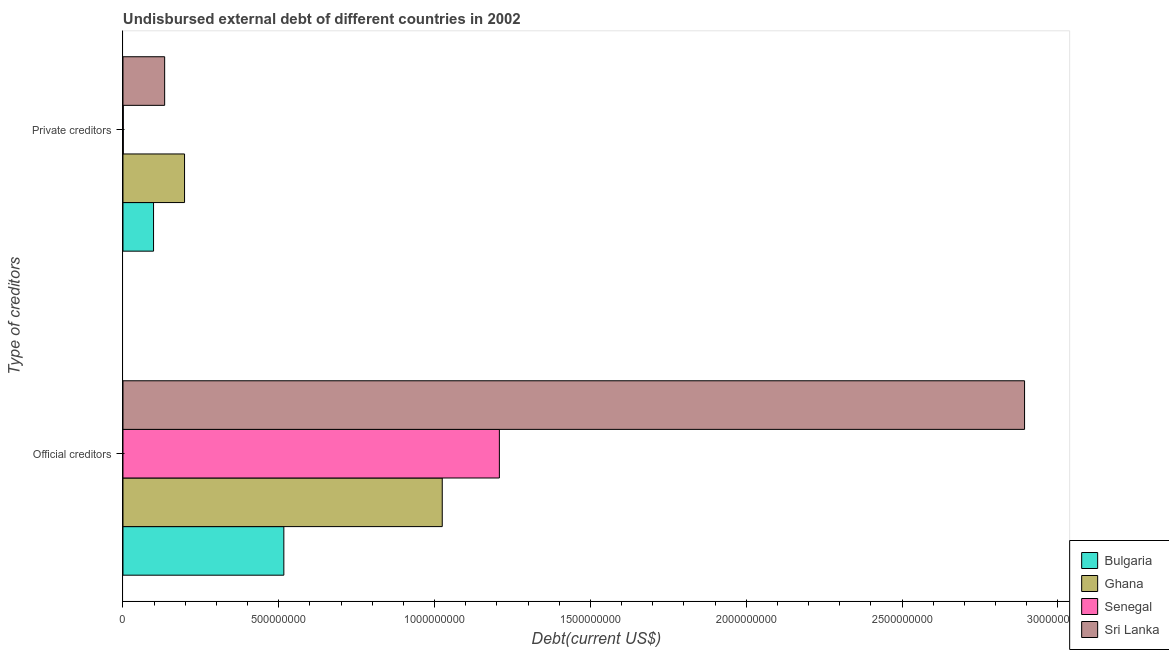How many different coloured bars are there?
Provide a short and direct response. 4. How many groups of bars are there?
Keep it short and to the point. 2. Are the number of bars per tick equal to the number of legend labels?
Your answer should be compact. Yes. Are the number of bars on each tick of the Y-axis equal?
Give a very brief answer. Yes. How many bars are there on the 2nd tick from the top?
Make the answer very short. 4. What is the label of the 1st group of bars from the top?
Ensure brevity in your answer.  Private creditors. What is the undisbursed external debt of private creditors in Ghana?
Offer a very short reply. 1.98e+08. Across all countries, what is the maximum undisbursed external debt of official creditors?
Offer a terse response. 2.89e+09. Across all countries, what is the minimum undisbursed external debt of private creditors?
Offer a very short reply. 9.55e+05. In which country was the undisbursed external debt of official creditors maximum?
Provide a succinct answer. Sri Lanka. In which country was the undisbursed external debt of private creditors minimum?
Your answer should be compact. Senegal. What is the total undisbursed external debt of official creditors in the graph?
Ensure brevity in your answer.  5.64e+09. What is the difference between the undisbursed external debt of private creditors in Sri Lanka and that in Senegal?
Make the answer very short. 1.33e+08. What is the difference between the undisbursed external debt of official creditors in Senegal and the undisbursed external debt of private creditors in Bulgaria?
Your response must be concise. 1.11e+09. What is the average undisbursed external debt of official creditors per country?
Ensure brevity in your answer.  1.41e+09. What is the difference between the undisbursed external debt of official creditors and undisbursed external debt of private creditors in Senegal?
Your answer should be compact. 1.21e+09. What is the ratio of the undisbursed external debt of private creditors in Bulgaria to that in Sri Lanka?
Provide a short and direct response. 0.73. In how many countries, is the undisbursed external debt of official creditors greater than the average undisbursed external debt of official creditors taken over all countries?
Offer a very short reply. 1. What does the 3rd bar from the top in Private creditors represents?
Keep it short and to the point. Ghana. What does the 4th bar from the bottom in Official creditors represents?
Provide a succinct answer. Sri Lanka. How many countries are there in the graph?
Your answer should be very brief. 4. What is the difference between two consecutive major ticks on the X-axis?
Provide a short and direct response. 5.00e+08. Are the values on the major ticks of X-axis written in scientific E-notation?
Your answer should be compact. No. How are the legend labels stacked?
Offer a very short reply. Vertical. What is the title of the graph?
Offer a terse response. Undisbursed external debt of different countries in 2002. Does "Cyprus" appear as one of the legend labels in the graph?
Your answer should be compact. No. What is the label or title of the X-axis?
Give a very brief answer. Debt(current US$). What is the label or title of the Y-axis?
Provide a short and direct response. Type of creditors. What is the Debt(current US$) in Bulgaria in Official creditors?
Your response must be concise. 5.16e+08. What is the Debt(current US$) of Ghana in Official creditors?
Make the answer very short. 1.02e+09. What is the Debt(current US$) in Senegal in Official creditors?
Your answer should be very brief. 1.21e+09. What is the Debt(current US$) of Sri Lanka in Official creditors?
Provide a succinct answer. 2.89e+09. What is the Debt(current US$) in Bulgaria in Private creditors?
Give a very brief answer. 9.81e+07. What is the Debt(current US$) in Ghana in Private creditors?
Give a very brief answer. 1.98e+08. What is the Debt(current US$) of Senegal in Private creditors?
Offer a terse response. 9.55e+05. What is the Debt(current US$) of Sri Lanka in Private creditors?
Your answer should be compact. 1.34e+08. Across all Type of creditors, what is the maximum Debt(current US$) in Bulgaria?
Offer a very short reply. 5.16e+08. Across all Type of creditors, what is the maximum Debt(current US$) in Ghana?
Your answer should be compact. 1.02e+09. Across all Type of creditors, what is the maximum Debt(current US$) in Senegal?
Give a very brief answer. 1.21e+09. Across all Type of creditors, what is the maximum Debt(current US$) of Sri Lanka?
Make the answer very short. 2.89e+09. Across all Type of creditors, what is the minimum Debt(current US$) of Bulgaria?
Keep it short and to the point. 9.81e+07. Across all Type of creditors, what is the minimum Debt(current US$) of Ghana?
Your answer should be very brief. 1.98e+08. Across all Type of creditors, what is the minimum Debt(current US$) in Senegal?
Your response must be concise. 9.55e+05. Across all Type of creditors, what is the minimum Debt(current US$) of Sri Lanka?
Offer a terse response. 1.34e+08. What is the total Debt(current US$) of Bulgaria in the graph?
Your answer should be compact. 6.14e+08. What is the total Debt(current US$) in Ghana in the graph?
Offer a terse response. 1.22e+09. What is the total Debt(current US$) in Senegal in the graph?
Make the answer very short. 1.21e+09. What is the total Debt(current US$) in Sri Lanka in the graph?
Make the answer very short. 3.03e+09. What is the difference between the Debt(current US$) of Bulgaria in Official creditors and that in Private creditors?
Your answer should be very brief. 4.18e+08. What is the difference between the Debt(current US$) of Ghana in Official creditors and that in Private creditors?
Offer a very short reply. 8.27e+08. What is the difference between the Debt(current US$) in Senegal in Official creditors and that in Private creditors?
Keep it short and to the point. 1.21e+09. What is the difference between the Debt(current US$) of Sri Lanka in Official creditors and that in Private creditors?
Provide a short and direct response. 2.76e+09. What is the difference between the Debt(current US$) in Bulgaria in Official creditors and the Debt(current US$) in Ghana in Private creditors?
Provide a succinct answer. 3.19e+08. What is the difference between the Debt(current US$) in Bulgaria in Official creditors and the Debt(current US$) in Senegal in Private creditors?
Offer a very short reply. 5.15e+08. What is the difference between the Debt(current US$) of Bulgaria in Official creditors and the Debt(current US$) of Sri Lanka in Private creditors?
Your answer should be compact. 3.82e+08. What is the difference between the Debt(current US$) in Ghana in Official creditors and the Debt(current US$) in Senegal in Private creditors?
Your answer should be compact. 1.02e+09. What is the difference between the Debt(current US$) of Ghana in Official creditors and the Debt(current US$) of Sri Lanka in Private creditors?
Give a very brief answer. 8.91e+08. What is the difference between the Debt(current US$) in Senegal in Official creditors and the Debt(current US$) in Sri Lanka in Private creditors?
Your response must be concise. 1.07e+09. What is the average Debt(current US$) of Bulgaria per Type of creditors?
Your answer should be very brief. 3.07e+08. What is the average Debt(current US$) of Ghana per Type of creditors?
Make the answer very short. 6.11e+08. What is the average Debt(current US$) in Senegal per Type of creditors?
Give a very brief answer. 6.04e+08. What is the average Debt(current US$) in Sri Lanka per Type of creditors?
Offer a very short reply. 1.51e+09. What is the difference between the Debt(current US$) of Bulgaria and Debt(current US$) of Ghana in Official creditors?
Your answer should be very brief. -5.08e+08. What is the difference between the Debt(current US$) of Bulgaria and Debt(current US$) of Senegal in Official creditors?
Your answer should be very brief. -6.92e+08. What is the difference between the Debt(current US$) of Bulgaria and Debt(current US$) of Sri Lanka in Official creditors?
Provide a short and direct response. -2.38e+09. What is the difference between the Debt(current US$) in Ghana and Debt(current US$) in Senegal in Official creditors?
Offer a terse response. -1.83e+08. What is the difference between the Debt(current US$) in Ghana and Debt(current US$) in Sri Lanka in Official creditors?
Provide a succinct answer. -1.87e+09. What is the difference between the Debt(current US$) of Senegal and Debt(current US$) of Sri Lanka in Official creditors?
Give a very brief answer. -1.69e+09. What is the difference between the Debt(current US$) of Bulgaria and Debt(current US$) of Ghana in Private creditors?
Your response must be concise. -9.95e+07. What is the difference between the Debt(current US$) in Bulgaria and Debt(current US$) in Senegal in Private creditors?
Offer a terse response. 9.72e+07. What is the difference between the Debt(current US$) of Bulgaria and Debt(current US$) of Sri Lanka in Private creditors?
Give a very brief answer. -3.57e+07. What is the difference between the Debt(current US$) in Ghana and Debt(current US$) in Senegal in Private creditors?
Offer a very short reply. 1.97e+08. What is the difference between the Debt(current US$) in Ghana and Debt(current US$) in Sri Lanka in Private creditors?
Provide a short and direct response. 6.38e+07. What is the difference between the Debt(current US$) in Senegal and Debt(current US$) in Sri Lanka in Private creditors?
Keep it short and to the point. -1.33e+08. What is the ratio of the Debt(current US$) of Bulgaria in Official creditors to that in Private creditors?
Keep it short and to the point. 5.26. What is the ratio of the Debt(current US$) of Ghana in Official creditors to that in Private creditors?
Your answer should be compact. 5.19. What is the ratio of the Debt(current US$) of Senegal in Official creditors to that in Private creditors?
Provide a short and direct response. 1264.81. What is the ratio of the Debt(current US$) of Sri Lanka in Official creditors to that in Private creditors?
Your answer should be very brief. 21.63. What is the difference between the highest and the second highest Debt(current US$) in Bulgaria?
Keep it short and to the point. 4.18e+08. What is the difference between the highest and the second highest Debt(current US$) in Ghana?
Offer a terse response. 8.27e+08. What is the difference between the highest and the second highest Debt(current US$) of Senegal?
Your response must be concise. 1.21e+09. What is the difference between the highest and the second highest Debt(current US$) of Sri Lanka?
Ensure brevity in your answer.  2.76e+09. What is the difference between the highest and the lowest Debt(current US$) in Bulgaria?
Keep it short and to the point. 4.18e+08. What is the difference between the highest and the lowest Debt(current US$) in Ghana?
Ensure brevity in your answer.  8.27e+08. What is the difference between the highest and the lowest Debt(current US$) in Senegal?
Your answer should be compact. 1.21e+09. What is the difference between the highest and the lowest Debt(current US$) of Sri Lanka?
Offer a terse response. 2.76e+09. 